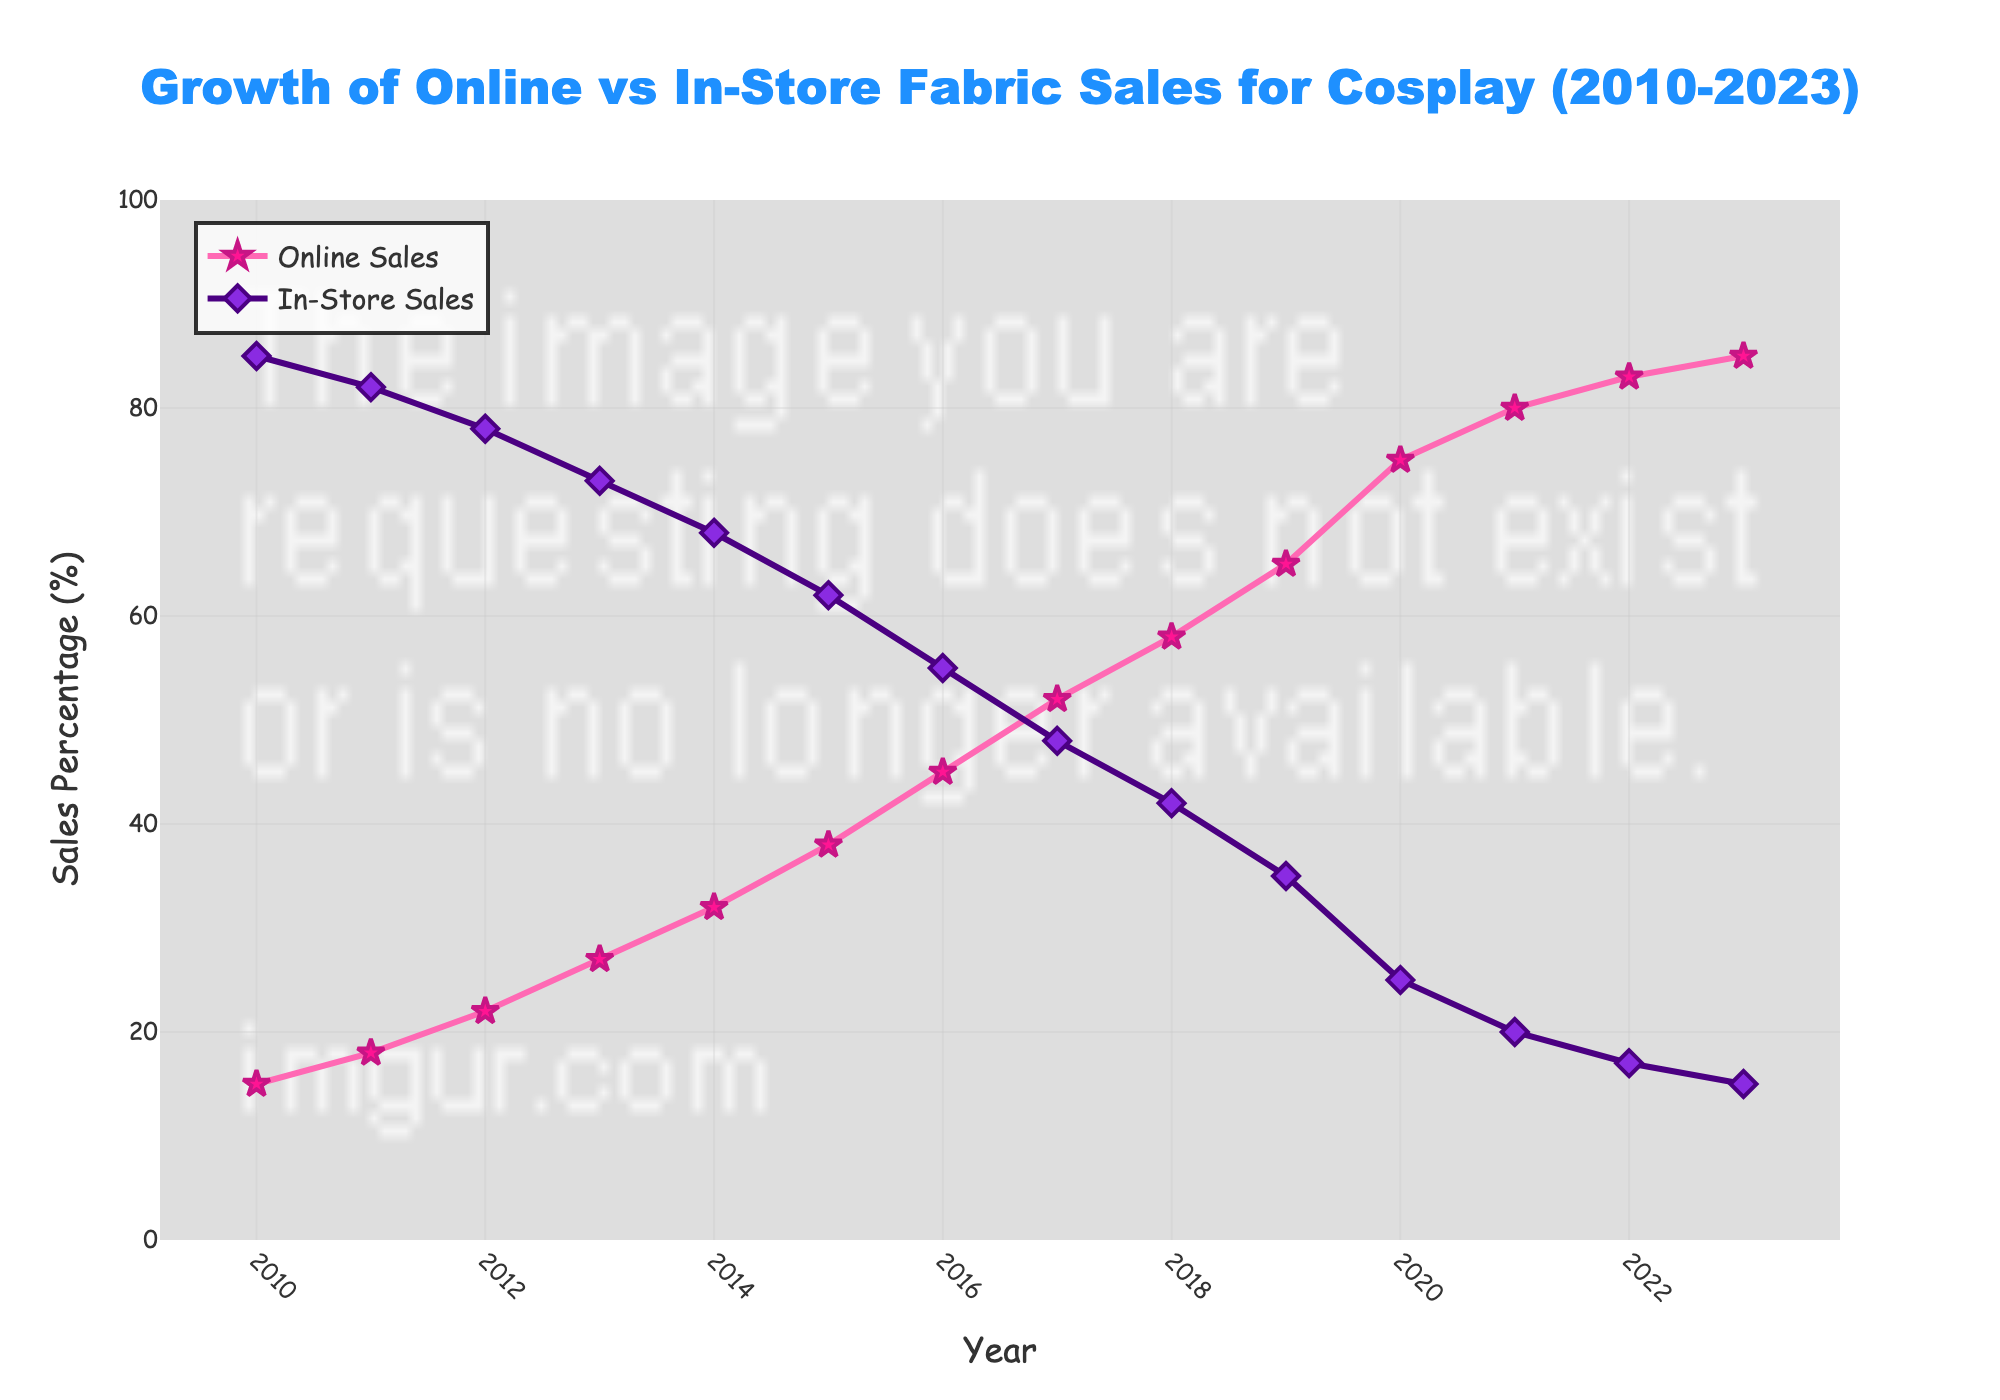What year does online fabric sales surpass in-store fabric sales? From the figure, we observe that online fabric sales surpass in-store fabric sales when the percentage of online sales becomes greater than that of in-store sales. This happens when the orange line (online sales) crosses above the purple line (in-store sales). This crossover occurs at year 2017.
Answer: 2017 What's the difference in online fabric sales between 2010 and 2023? By locating the points for online fabric sales in 2010 and 2023, we observe the sales percentages for these years are 15% and 85% respectively. The difference can be calculated as 85% - 15% = 70%.
Answer: 70% How many years did it take for online fabric sales to reach 50% starting from 2010? We need to find the year when online fabric sales reached 50% for the first time. By tracing the online sales line (orange), we notice it hits 50% in the year 2017. Therefore, it took 2017 - 2010 = 7 years.
Answer: 7 years What is the percentage change in in-store fabric sales from 2010 to 2023? The in-store fabric sales percentage in 2010 is 85% and in 2023 is 15%. To find the percentage change, we use the formula: (new value - old value) / old value * 100. Thus, (15% - 85%) / 85% * 100 = -82.35%.
Answer: -82.35% By how much did online fabric sales increase from 2014 to 2020? The percentage of online fabric sales in 2014 is 32%, and in 2020 is 75%. The increase is calculated as 75% - 32%, which results in 43%.
Answer: 43% What was the average percentage of online fabric sales for the years 2010, 2012, and 2014? The respective percentages for online fabric sales in 2010, 2012, and 2014 are 15%, 22%, and 32%. The average is calculated as (15% + 22% + 32%) / 3 = 23%.
Answer: 23% Which year had the smallest gap in percentages between online and in-store fabric sales? To determine the smallest gap, we need to look at each year’s difference between online and in-store sales. The year 2017 shows the smallest gap, where the sales percentages are 52% (online) and 48% (in-store), giving a difference of 4%.
Answer: 2017 In which year did both online and in-store fabric sales percentages add up to 100 for the first time? Observing each year, the sum of percentages for online and in-store sales always equals 100%. Furthermore, this is true from the starting year, 2010.
Answer: 2010 